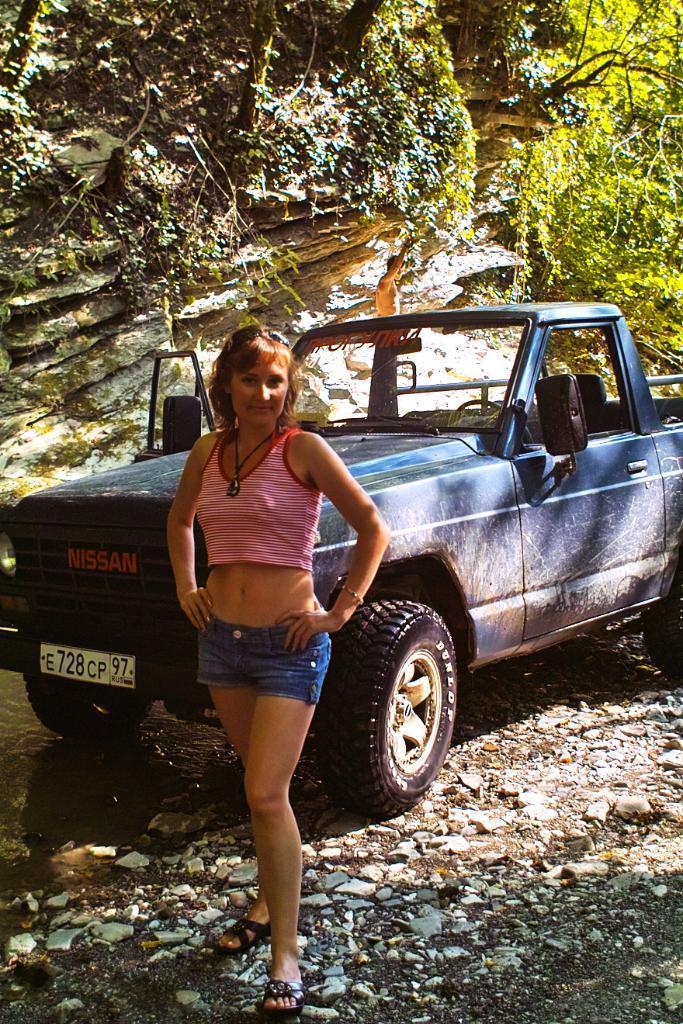Could you give a brief overview of what you see in this image? In this image we can see a lady standing. Near to her there is a vehicle. On the ground there are stones. Also there is water. In the background there are trees and rocks. Also there is a rock. 